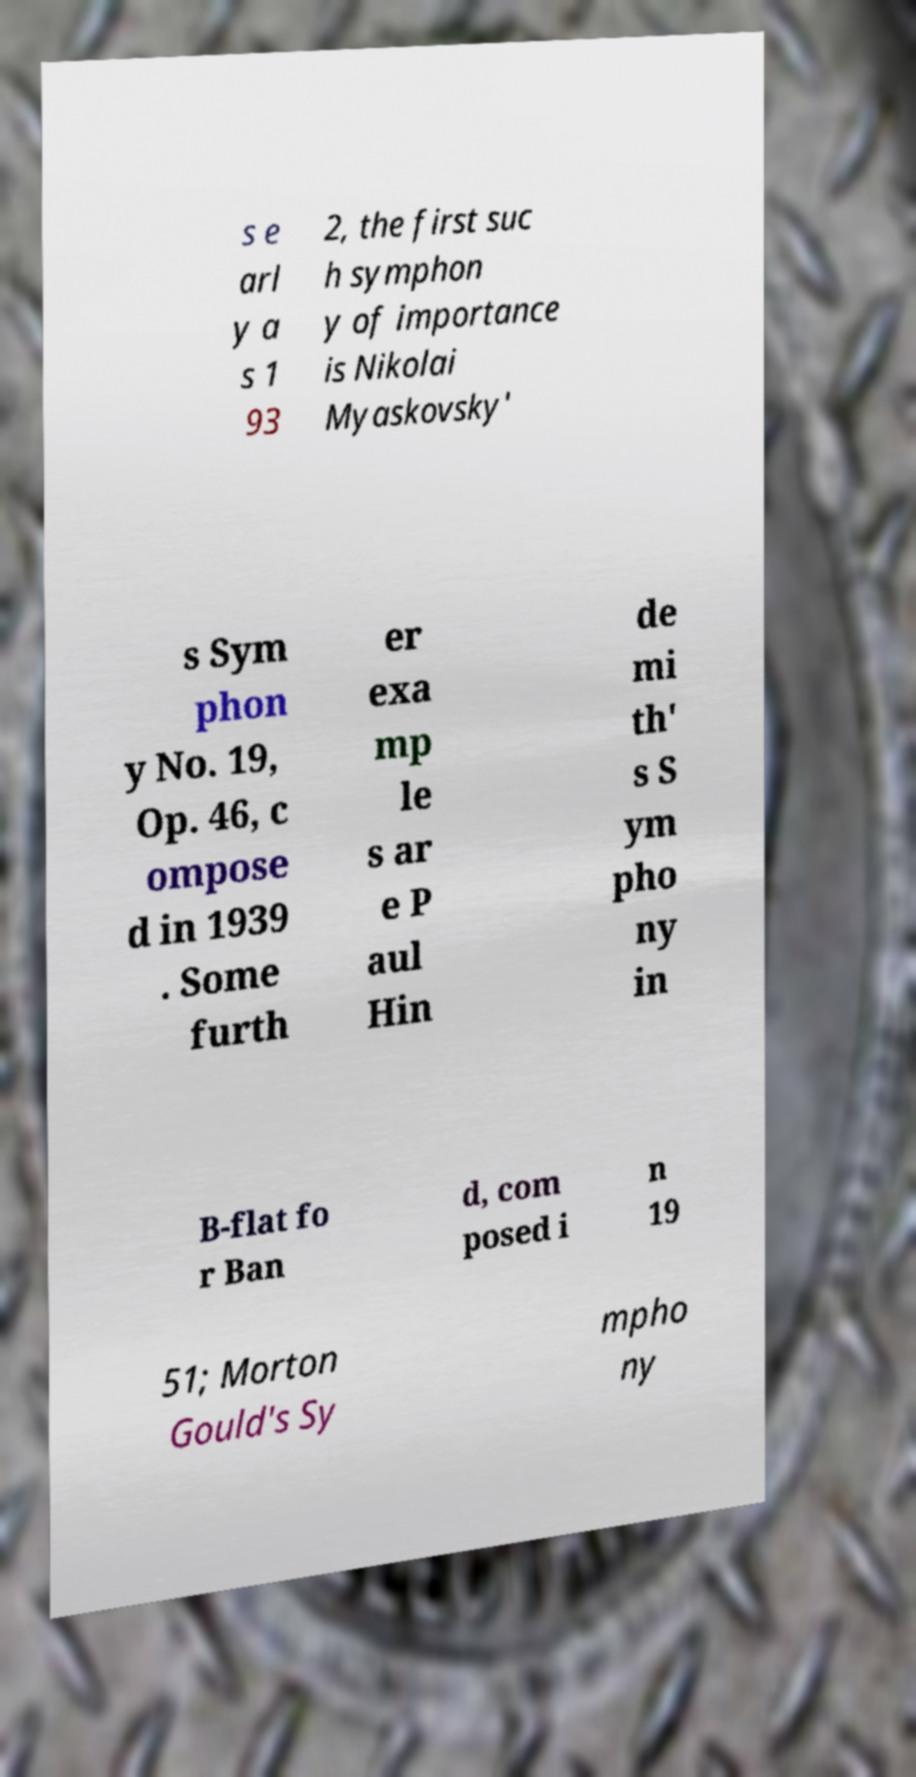Could you assist in decoding the text presented in this image and type it out clearly? s e arl y a s 1 93 2, the first suc h symphon y of importance is Nikolai Myaskovsky' s Sym phon y No. 19, Op. 46, c ompose d in 1939 . Some furth er exa mp le s ar e P aul Hin de mi th' s S ym pho ny in B-flat fo r Ban d, com posed i n 19 51; Morton Gould's Sy mpho ny 